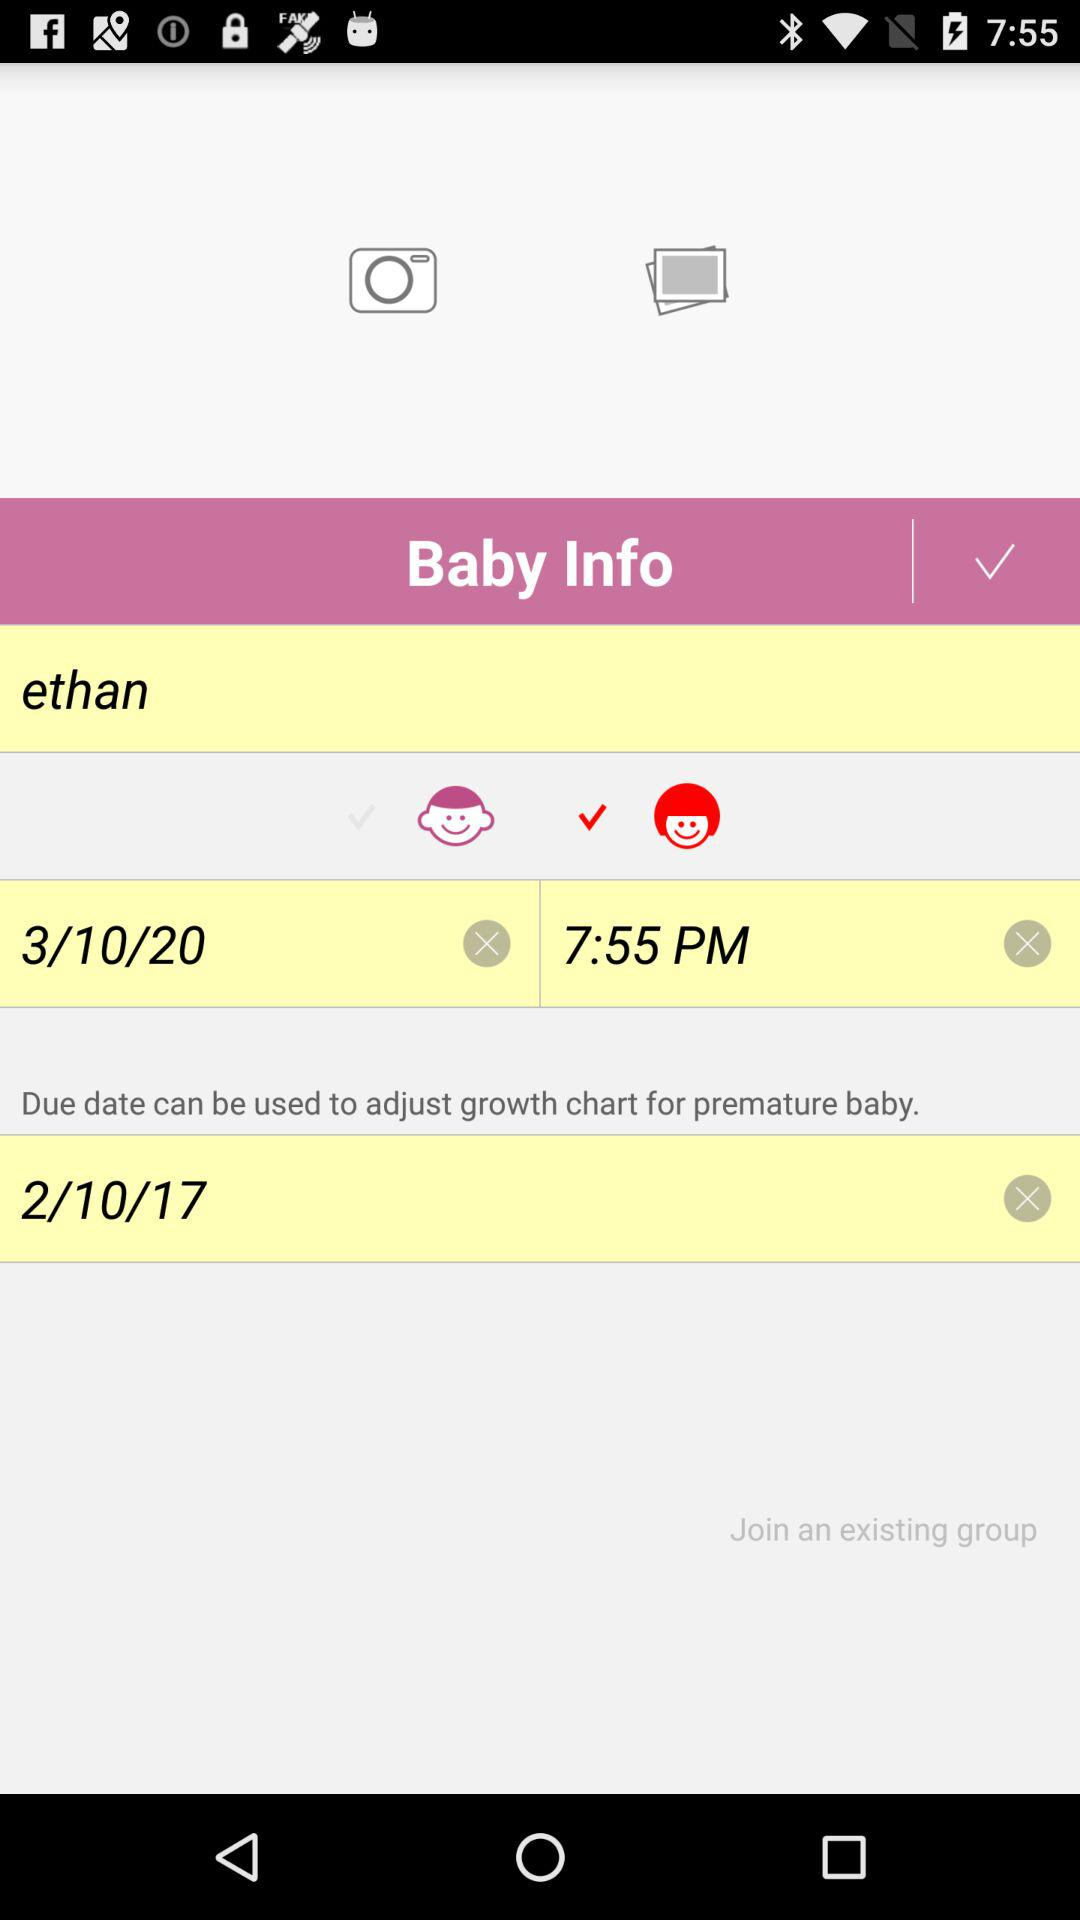What is the mentioned time? The mentioned time is 7:55 PM. 